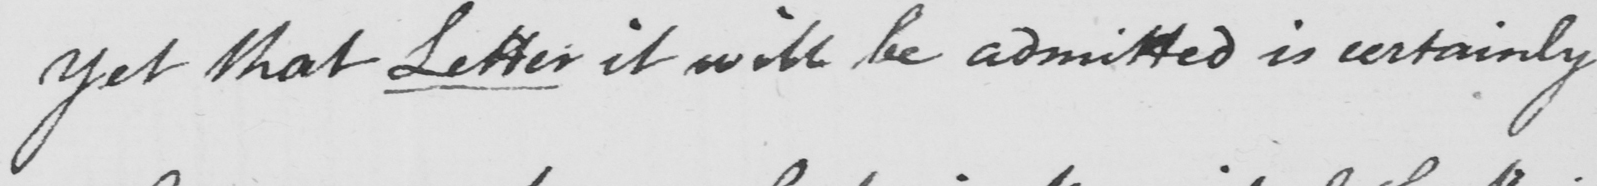Please transcribe the handwritten text in this image. yet that Letter it will be admitted is certainly 